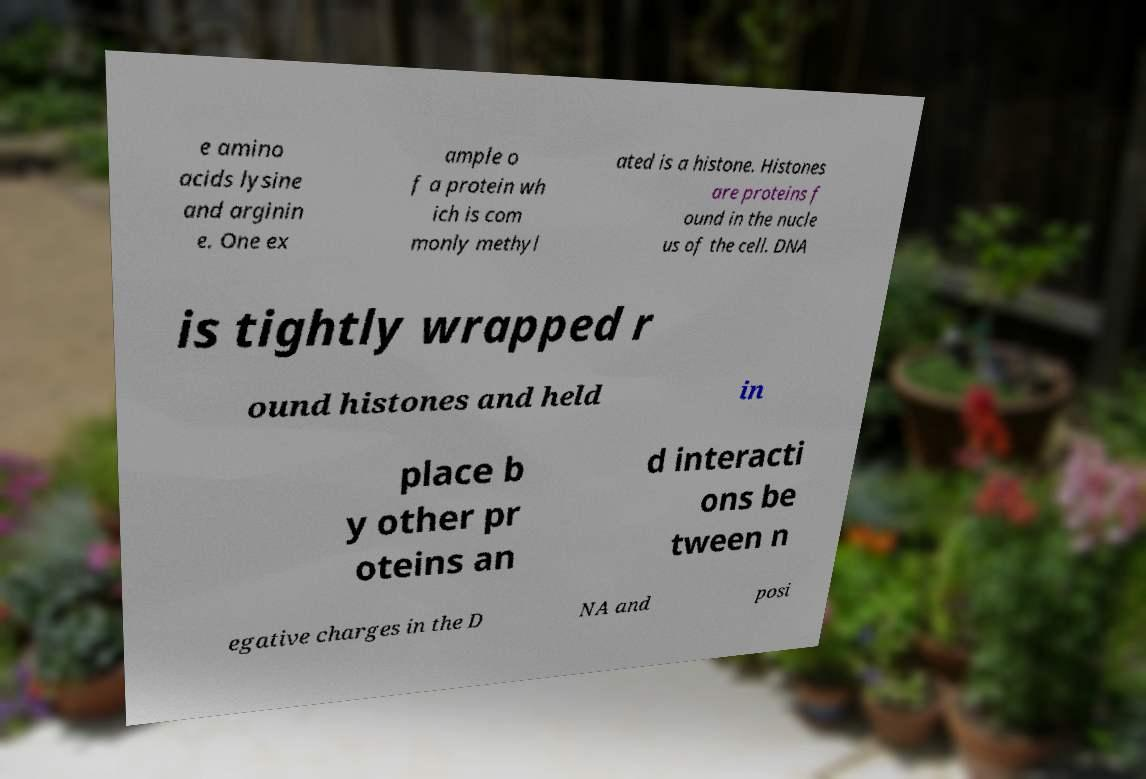What messages or text are displayed in this image? I need them in a readable, typed format. e amino acids lysine and arginin e. One ex ample o f a protein wh ich is com monly methyl ated is a histone. Histones are proteins f ound in the nucle us of the cell. DNA is tightly wrapped r ound histones and held in place b y other pr oteins an d interacti ons be tween n egative charges in the D NA and posi 